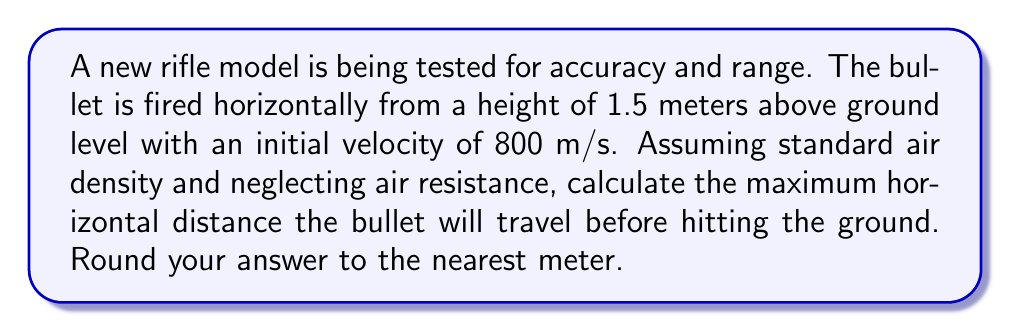Could you help me with this problem? To solve this problem, we'll use the equations of motion for projectile motion, considering that the bullet is fired horizontally.

Given:
- Initial height (h) = 1.5 m
- Initial velocity (v₀) = 800 m/s
- Acceleration due to gravity (g) = 9.8 m/s²

Step 1: Determine the time it takes for the bullet to hit the ground.
Using the equation for vertical displacement:

$$ y = y_0 + v_0t + \frac{1}{2}gt^2 $$

Where y = 0 (ground level), y₀ = 1.5 m, v₀ (vertical) = 0 m/s

$$ 0 = 1.5 + 0 + \frac{1}{2}(9.8)t^2 $$
$$ -1.5 = 4.9t^2 $$
$$ t^2 = \frac{1.5}{4.9} $$
$$ t = \sqrt{\frac{1.5}{4.9}} \approx 0.5528 \text{ seconds} $$

Step 2: Calculate the horizontal distance traveled.
Using the equation for horizontal motion (constant velocity):

$$ x = v_0t $$

Where v₀ = 800 m/s and t = 0.5528 s

$$ x = 800 \cdot 0.5528 = 442.24 \text{ meters} $$

Step 3: Round to the nearest meter.

442.24 meters rounds to 442 meters.
Answer: 442 meters 